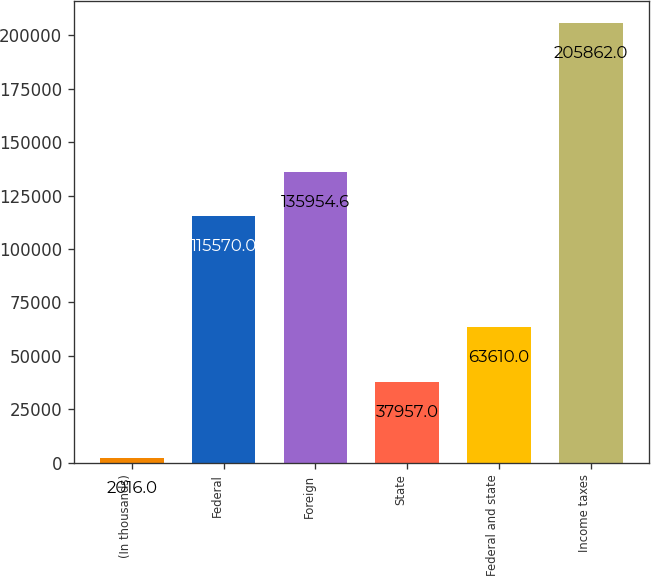<chart> <loc_0><loc_0><loc_500><loc_500><bar_chart><fcel>(In thousands)<fcel>Federal<fcel>Foreign<fcel>State<fcel>Federal and state<fcel>Income taxes<nl><fcel>2016<fcel>115570<fcel>135955<fcel>37957<fcel>63610<fcel>205862<nl></chart> 